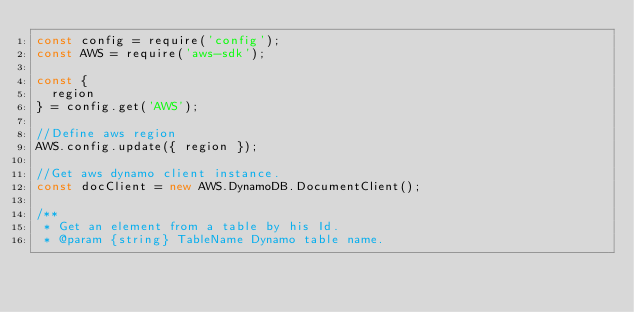Convert code to text. <code><loc_0><loc_0><loc_500><loc_500><_JavaScript_>const config = require('config');
const AWS = require('aws-sdk');

const {
  region
} = config.get('AWS');

//Define aws region
AWS.config.update({ region });

//Get aws dynamo client instance.
const docClient = new AWS.DynamoDB.DocumentClient();

/**
 * Get an element from a table by his Id.
 * @param {string} TableName Dynamo table name.</code> 